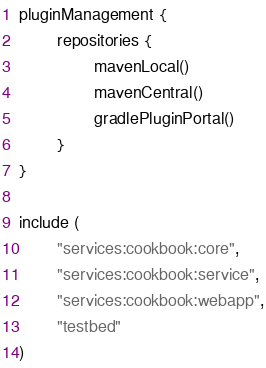<code> <loc_0><loc_0><loc_500><loc_500><_Kotlin_>pluginManagement {
        repositories {
                mavenLocal()
                mavenCentral()
                gradlePluginPortal()
        }
}

include (
        "services:cookbook:core",
        "services:cookbook:service",
        "services:cookbook:webapp",
        "testbed"
)

</code> 